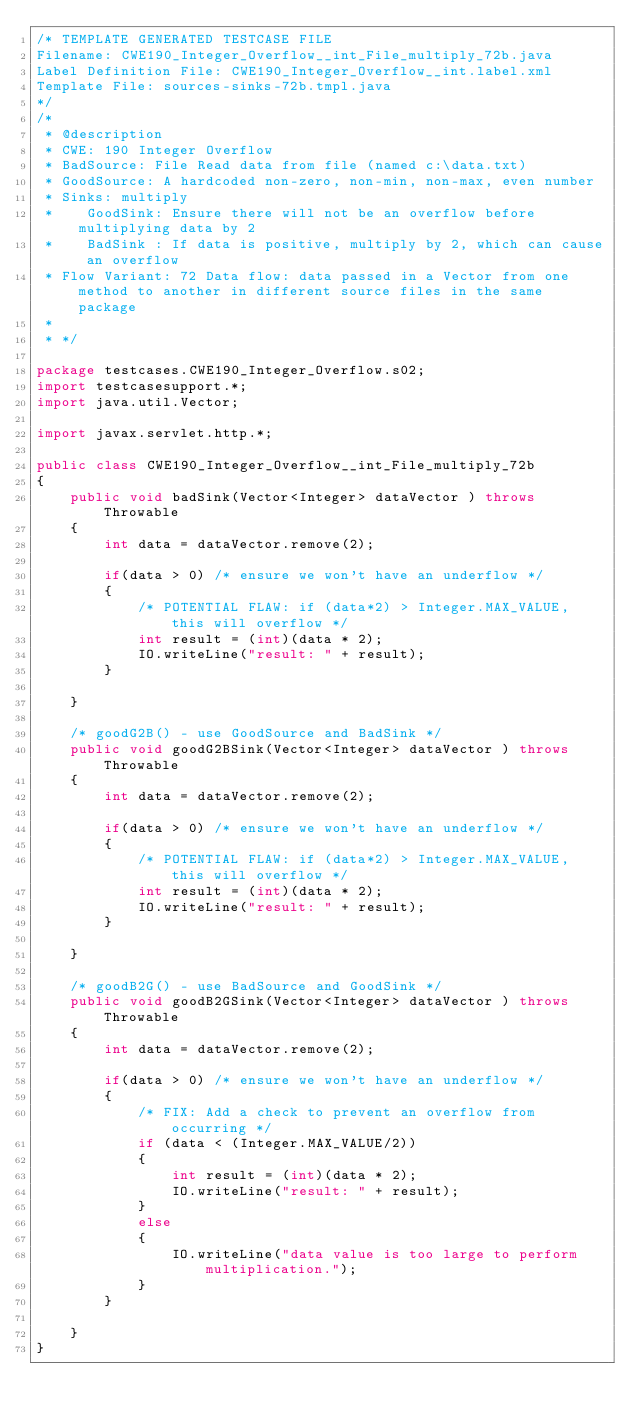Convert code to text. <code><loc_0><loc_0><loc_500><loc_500><_Java_>/* TEMPLATE GENERATED TESTCASE FILE
Filename: CWE190_Integer_Overflow__int_File_multiply_72b.java
Label Definition File: CWE190_Integer_Overflow__int.label.xml
Template File: sources-sinks-72b.tmpl.java
*/
/*
 * @description
 * CWE: 190 Integer Overflow
 * BadSource: File Read data from file (named c:\data.txt)
 * GoodSource: A hardcoded non-zero, non-min, non-max, even number
 * Sinks: multiply
 *    GoodSink: Ensure there will not be an overflow before multiplying data by 2
 *    BadSink : If data is positive, multiply by 2, which can cause an overflow
 * Flow Variant: 72 Data flow: data passed in a Vector from one method to another in different source files in the same package
 *
 * */

package testcases.CWE190_Integer_Overflow.s02;
import testcasesupport.*;
import java.util.Vector;

import javax.servlet.http.*;

public class CWE190_Integer_Overflow__int_File_multiply_72b
{
    public void badSink(Vector<Integer> dataVector ) throws Throwable
    {
        int data = dataVector.remove(2);

        if(data > 0) /* ensure we won't have an underflow */
        {
            /* POTENTIAL FLAW: if (data*2) > Integer.MAX_VALUE, this will overflow */
            int result = (int)(data * 2);
            IO.writeLine("result: " + result);
        }

    }

    /* goodG2B() - use GoodSource and BadSink */
    public void goodG2BSink(Vector<Integer> dataVector ) throws Throwable
    {
        int data = dataVector.remove(2);

        if(data > 0) /* ensure we won't have an underflow */
        {
            /* POTENTIAL FLAW: if (data*2) > Integer.MAX_VALUE, this will overflow */
            int result = (int)(data * 2);
            IO.writeLine("result: " + result);
        }

    }

    /* goodB2G() - use BadSource and GoodSink */
    public void goodB2GSink(Vector<Integer> dataVector ) throws Throwable
    {
        int data = dataVector.remove(2);

        if(data > 0) /* ensure we won't have an underflow */
        {
            /* FIX: Add a check to prevent an overflow from occurring */
            if (data < (Integer.MAX_VALUE/2))
            {
                int result = (int)(data * 2);
                IO.writeLine("result: " + result);
            }
            else
            {
                IO.writeLine("data value is too large to perform multiplication.");
            }
        }

    }
}
</code> 